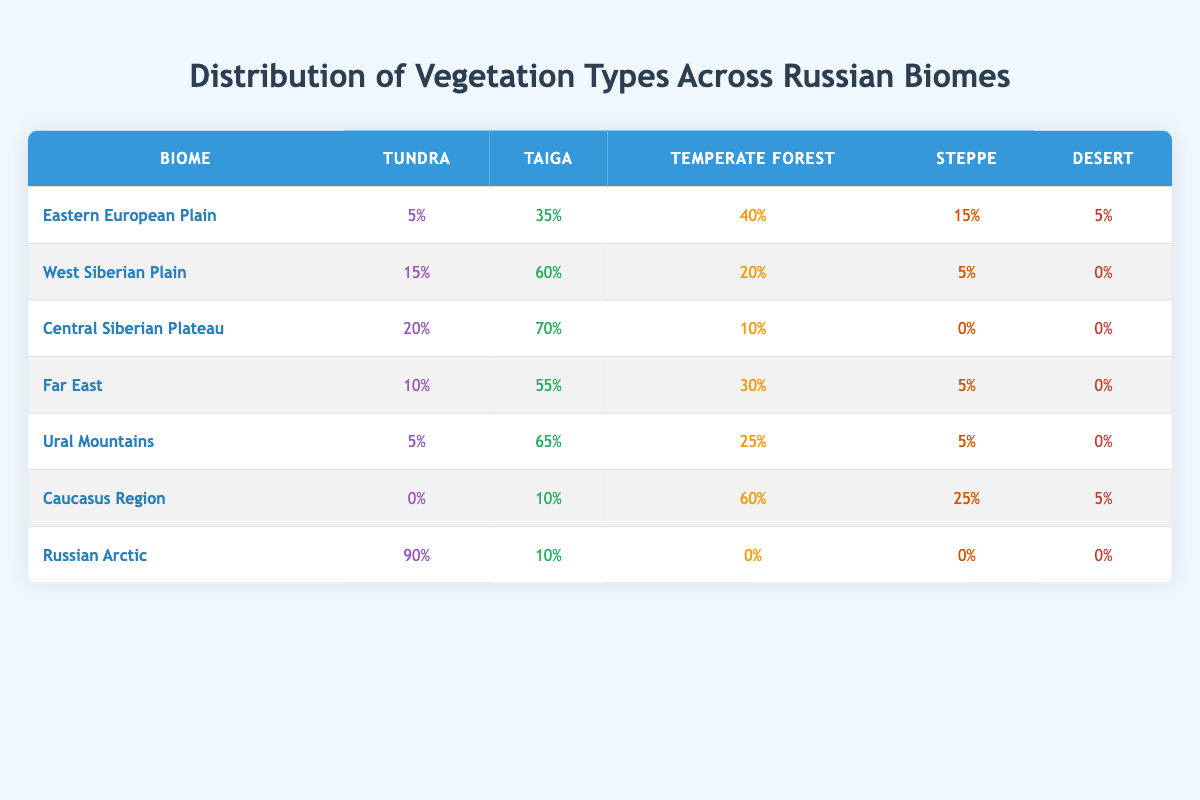What percentage of the Ural Mountains is covered by Taiga? The Ural Mountains show a Taiga coverage of 65%, which is directly stated in the table.
Answer: 65% Which biome has the highest percentage of Tundra vegetation? The table indicates that the Russian Arctic has 90% Tundra vegetation, making it the highest for this category.
Answer: 90% What is the combined percentage of Steppe vegetation in the Eastern European Plain and the Caucasus Region? The Eastern European Plain has 15% Steppe, while the Caucasus Region has 25% Steppe. Summing these gives 15 + 25 = 40%.
Answer: 40% Is there any area in Russia where Desert vegetation is present? According to the table, the Desert category has entries in both the Eastern European Plain (5%) and Caucasus Region (5%), confirming that Desert vegetation is present.
Answer: Yes In which region is Temperate Forest vegetation the most prevalent, and what is its percentage? The table reveals that the Caucasus Region has the highest Temperate Forest coverage at 60%.
Answer: Caucasus Region, 60% What is the average percentage of Tundra across all regions listed in the table? To find the average Tundra percentage, we need to add all Tundra values: 5% + 15% + 20% + 10% + 5% + 0% + 90% = 145%. There are 7 regions, so the average is 145/7 = approximately 20.71%.
Answer: Approximately 20.71% What percentage of the Central Siberian Plateau is covered by Temperate Forest and Desert combined? The Central Siberian Plateau has 10% Temperate Forest and 0% Desert. Adding these gives 10 + 0 = 10%.
Answer: 10% In terms of Tundra coverage, is the Ural Mountains more similar to the Eastern European Plain or the Russian Arctic? The Ural Mountains have 5% Tundra, while the Eastern European Plain has 5% as well, and the Russian Arctic has 90%. The Ural Mountains are similar to the Eastern European Plain in Tundra coverage.
Answer: Eastern European Plain Which region has the least amount of Desert vegetation and what is that percentage? The table shows that the West Siberian Plain has 0% Desert vegetation, indicating it has the least.
Answer: West Siberian Plain, 0% 